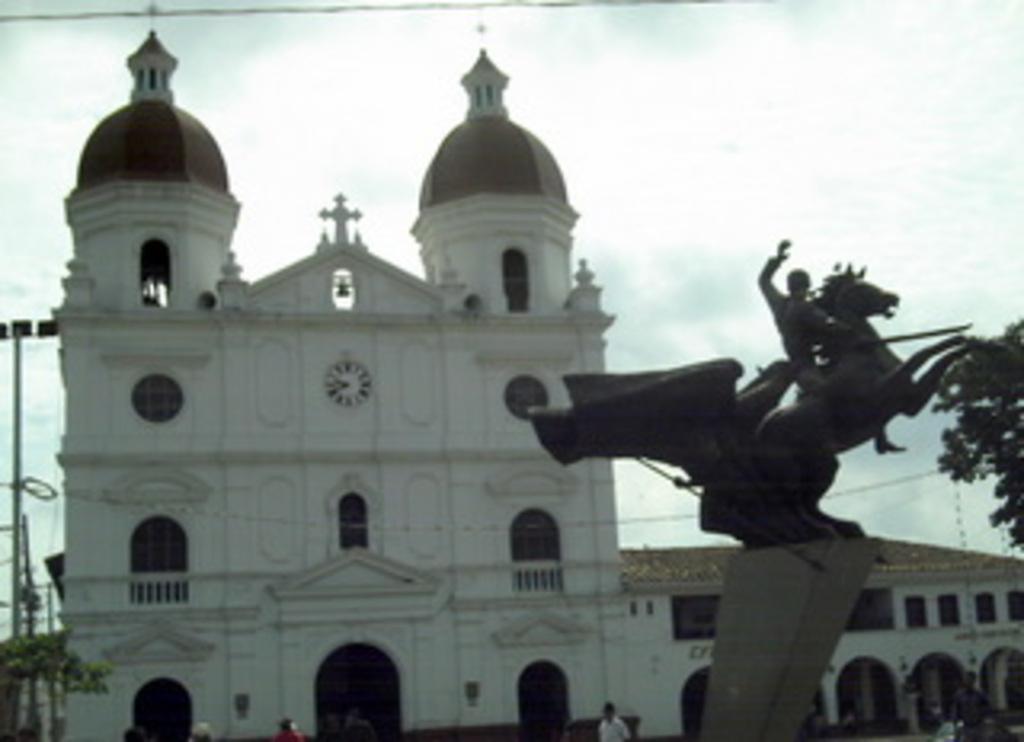Describe this image in one or two sentences. In this image on the right side there statues, and wall and in the background there are buildings, trees, wires, poles. And at the bottom there are some persons walking, and at the top there is sky. 